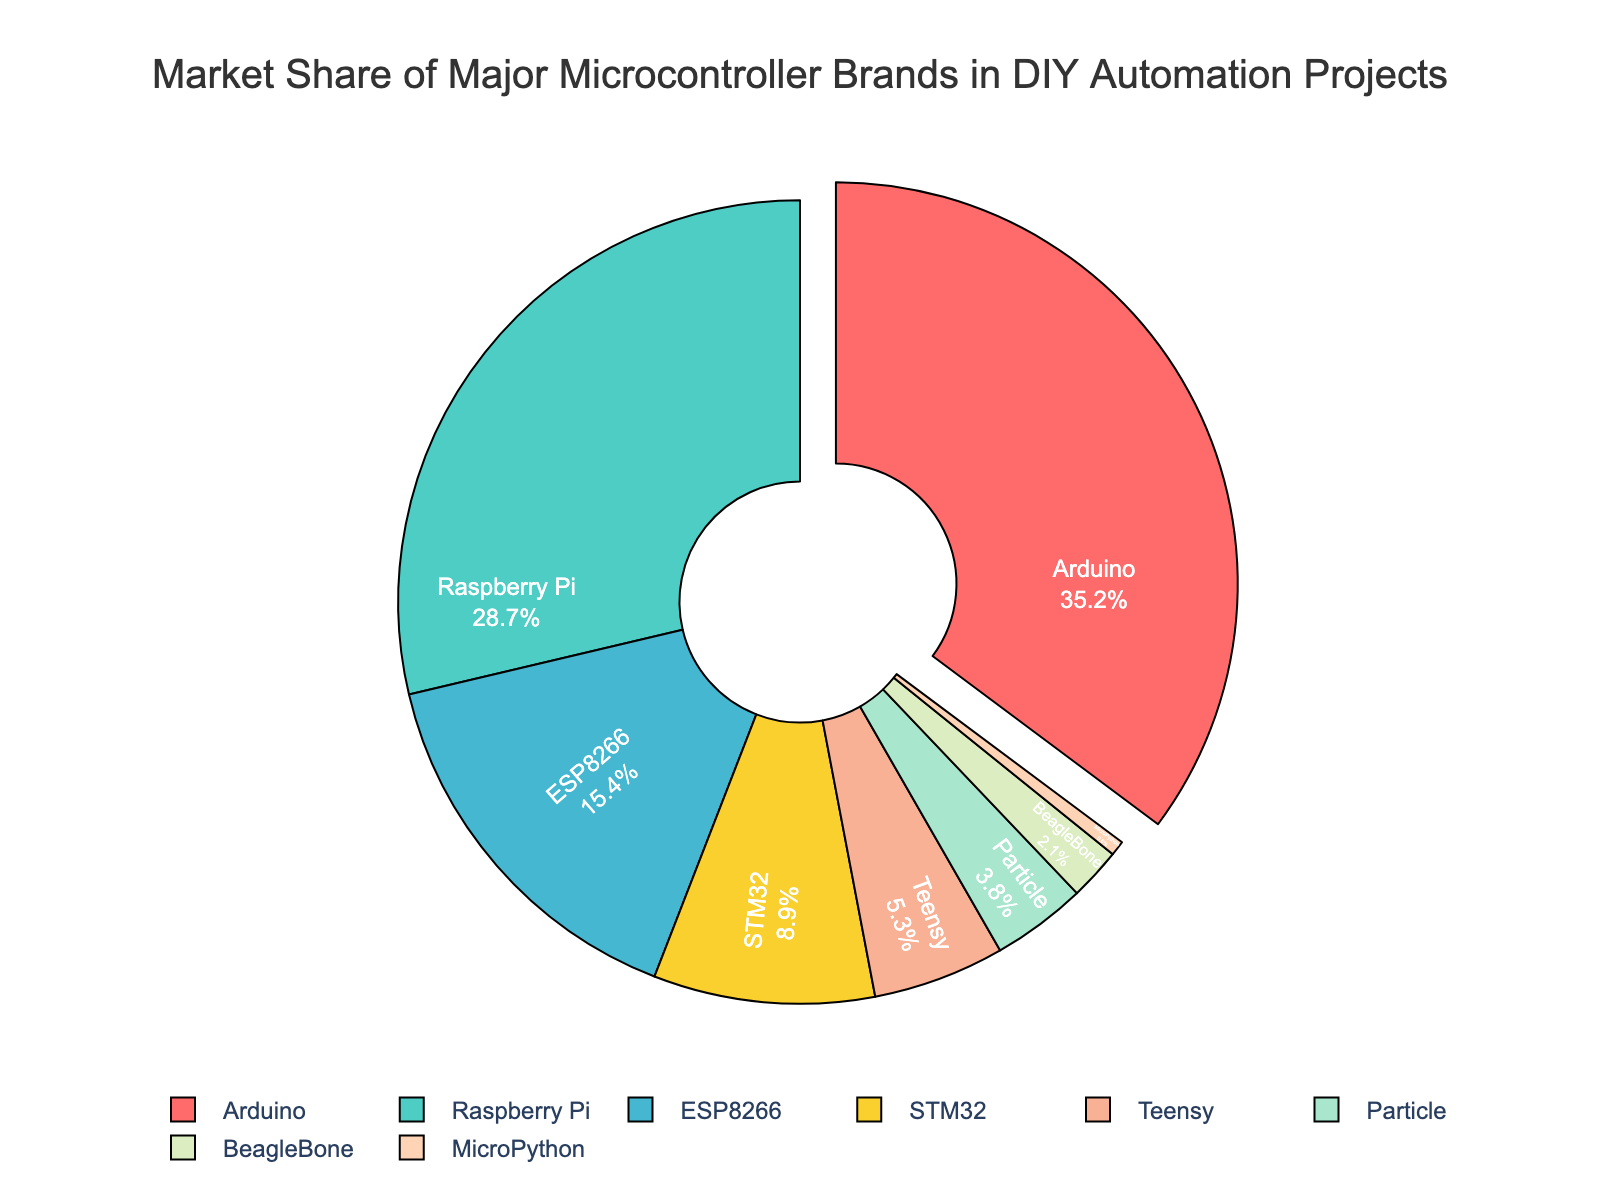Which brand has the highest market share? The figure clearly shows that Arduino has the highest market share. It is represented by the largest segment of the pie chart and indicated by the percentage next to it.
Answer: Arduino How much more market share does Arduino have compared to ESP8266? Arduino has 35.2% market share and ESP8266 has 15.4%. The difference is calculated by subtracting ESP8266's share from Arduino's share: 35.2 - 15.4 = 19.8%.
Answer: 19.8% Which three brands have the smallest market shares, and what are their combined percentages? The three brands with the smallest market shares are MicroPython (0.6%), BeagleBone (2.1%), and Particle (3.8%). Summing these percentages gives 0.6 + 2.1 + 3.8 = 6.5%.
Answer: MicroPython, BeagleBone, Particle - 6.5% Which brand has a market share closest to 30%? The brand with a market share closest to 30% is Raspberry Pi, which has 28.7%. This can be identified by examining the percentages shown inside the chart segments.
Answer: Raspberry Pi Is the combined market share of STM32 and Teensy greater than that of Raspberry Pi? STM32 has 8.9% and Teensy has 5.3%. Combined, they have 8.9 + 5.3 = 14.2%. Raspberry Pi alone has 28.7%. Therefore, 14.2% is not greater than 28.7%.
Answer: No What is the market share of brands other than Arduino and Raspberry Pi? By subtracting the market shares of Arduino (35.2%) and Raspberry Pi (28.7%) from 100%, we get: 100 - 35.2 - 28.7 = 36.1%.
Answer: 36.1% Which brand is represented by the light blue segment in the pie chart? The light blue segment represents the ESP8266, which can be identified from the color legend provided in the chart.
Answer: ESP8266 Are there more brands with market share above or below 10%? Brands above 10% are Arduino (35.2%), Raspberry Pi (28.7%), and ESP8266 (15.4%), totaling three brands. Brands below 10% are STM32 (8.9%), Teensy (5.3%), Particle (3.8%), BeagleBone (2.1%), and MicroPython (0.6%), totaling five brands. Thus, more brands are below 10%.
Answer: Below 10% What's the visual representation technique used to highlight the most popular brand? The figure uses a pie chart with a "pull-out" effect on the most popular segment, which is Arduino, pulling it slightly out from the rest of the chart to emphasize its dominance.
Answer: Pull-out effect Which brands have a market share within the range of 5% to 10%? The brands that have a market share in the 5% to 10% range are STM32 (8.9%) and Teensy (5.3%), as indicated by the percentages inside the segments.
Answer: STM32, Teensy 